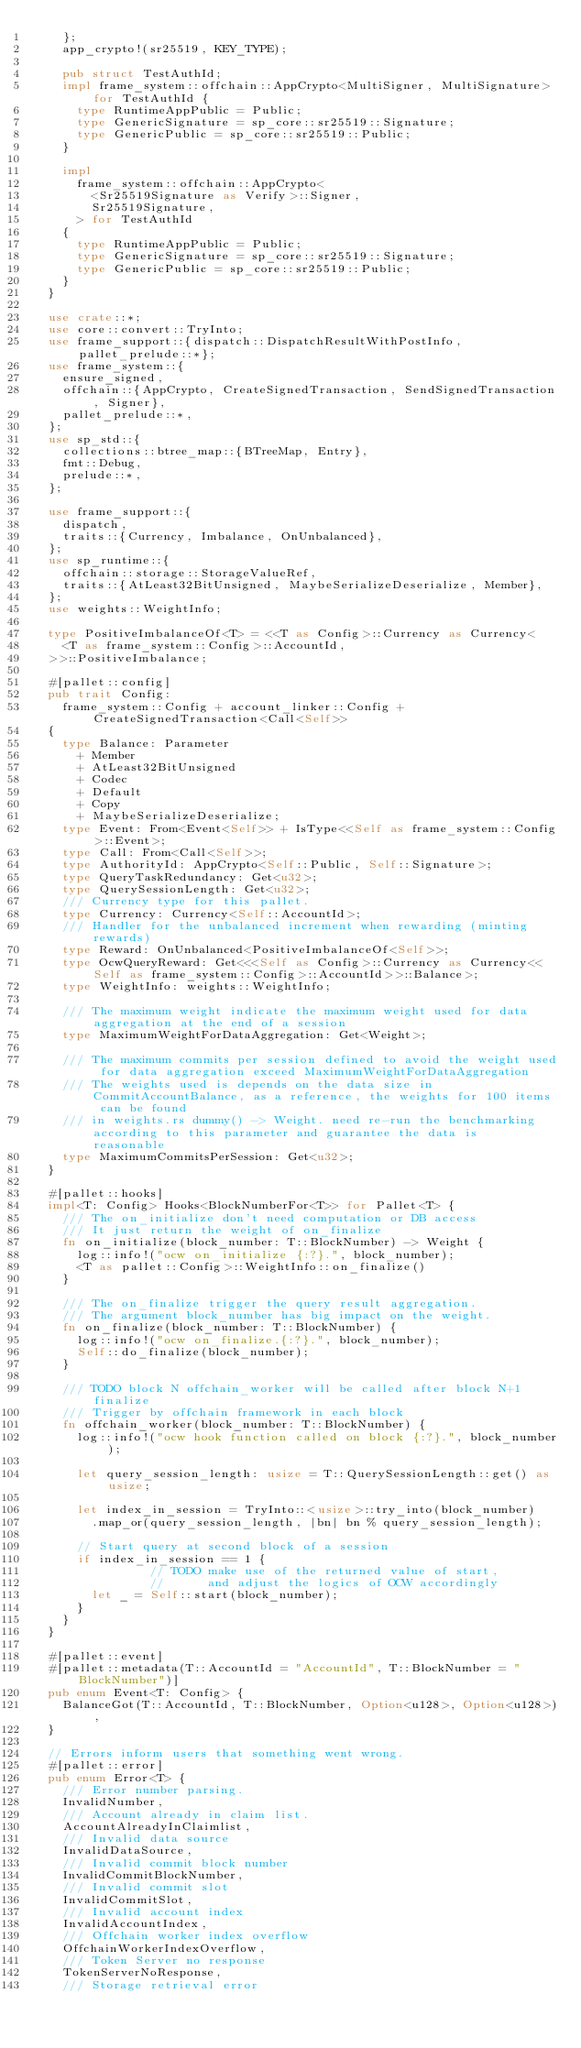<code> <loc_0><loc_0><loc_500><loc_500><_Rust_>		};
		app_crypto!(sr25519, KEY_TYPE);

		pub struct TestAuthId;
		impl frame_system::offchain::AppCrypto<MultiSigner, MultiSignature> for TestAuthId {
			type RuntimeAppPublic = Public;
			type GenericSignature = sp_core::sr25519::Signature;
			type GenericPublic = sp_core::sr25519::Public;
		}

		impl
			frame_system::offchain::AppCrypto<
				<Sr25519Signature as Verify>::Signer,
				Sr25519Signature,
			> for TestAuthId
		{
			type RuntimeAppPublic = Public;
			type GenericSignature = sp_core::sr25519::Signature;
			type GenericPublic = sp_core::sr25519::Public;
		}
	}

	use crate::*;
	use core::convert::TryInto;
	use frame_support::{dispatch::DispatchResultWithPostInfo, pallet_prelude::*};
	use frame_system::{
		ensure_signed,
		offchain::{AppCrypto, CreateSignedTransaction, SendSignedTransaction, Signer},
		pallet_prelude::*,
	};
	use sp_std::{
		collections::btree_map::{BTreeMap, Entry},
		fmt::Debug,
		prelude::*,
	};

	use frame_support::{
		dispatch,
		traits::{Currency, Imbalance, OnUnbalanced},
	};
	use sp_runtime::{
		offchain::storage::StorageValueRef,
		traits::{AtLeast32BitUnsigned, MaybeSerializeDeserialize, Member},
	};
	use weights::WeightInfo;

	type PositiveImbalanceOf<T> = <<T as Config>::Currency as Currency<
		<T as frame_system::Config>::AccountId,
	>>::PositiveImbalance;

	#[pallet::config]
	pub trait Config:
		frame_system::Config + account_linker::Config + CreateSignedTransaction<Call<Self>>
	{
		type Balance: Parameter
			+ Member
			+ AtLeast32BitUnsigned
			+ Codec
			+ Default
			+ Copy
			+ MaybeSerializeDeserialize;
		type Event: From<Event<Self>> + IsType<<Self as frame_system::Config>::Event>;
		type Call: From<Call<Self>>;
		type AuthorityId: AppCrypto<Self::Public, Self::Signature>;
		type QueryTaskRedundancy: Get<u32>;
		type QuerySessionLength: Get<u32>;
		/// Currency type for this pallet.
		type Currency: Currency<Self::AccountId>;
		/// Handler for the unbalanced increment when rewarding (minting rewards)
		type Reward: OnUnbalanced<PositiveImbalanceOf<Self>>;
		type OcwQueryReward: Get<<<Self as Config>::Currency as Currency<<Self as frame_system::Config>::AccountId>>::Balance>;
		type WeightInfo: weights::WeightInfo;

		/// The maximum weight indicate the maximum weight used for data aggregation at the end of a session
		type MaximumWeightForDataAggregation: Get<Weight>;

		/// The maximum commits per session defined to avoid the weight used for data aggregation exceed MaximumWeightForDataAggregation
		/// The weights used is depends on the data size in CommitAccountBalance, as a reference, the weights for 100 items can be found
		/// in weights.rs dummy() -> Weight. need re-run the benchmarking according to this parameter and guarantee the data is reasonable
		type MaximumCommitsPerSession: Get<u32>;
	}

	#[pallet::hooks]
	impl<T: Config> Hooks<BlockNumberFor<T>> for Pallet<T> {
		/// The on_initialize don't need computation or DB access
		/// It just return the weight of on_finalize
		fn on_initialize(block_number: T::BlockNumber) -> Weight {
			log::info!("ocw on_initialize {:?}.", block_number);
			<T as pallet::Config>::WeightInfo::on_finalize()
		}

		/// The on_finalize trigger the query result aggregation.
		/// The argument block_number has big impact on the weight.
		fn on_finalize(block_number: T::BlockNumber) {
			log::info!("ocw on_finalize.{:?}.", block_number);
			Self::do_finalize(block_number);
		}

		/// TODO block N offchain_worker will be called after block N+1 finalize
		/// Trigger by offchain framework in each block
		fn offchain_worker(block_number: T::BlockNumber) {
			log::info!("ocw hook function called on block {:?}.", block_number);

			let query_session_length: usize = T::QuerySessionLength::get() as usize;

			let index_in_session = TryInto::<usize>::try_into(block_number)
				.map_or(query_session_length, |bn| bn % query_session_length);

			// Start query at second block of a session
			if index_in_session == 1 {
                // TODO make use of the returned value of start,
                //      and adjust the logics of OCW accordingly
				let _ = Self::start(block_number);
			}
		}
	}

	#[pallet::event]
	#[pallet::metadata(T::AccountId = "AccountId", T::BlockNumber = "BlockNumber")]
	pub enum Event<T: Config> {
		BalanceGot(T::AccountId, T::BlockNumber, Option<u128>, Option<u128>),
	}

	// Errors inform users that something went wrong.
	#[pallet::error]
	pub enum Error<T> {
		/// Error number parsing.
		InvalidNumber,
		/// Account already in claim list.
		AccountAlreadyInClaimlist,
		/// Invalid data source
		InvalidDataSource,
		/// Invalid commit block number
		InvalidCommitBlockNumber,
		/// Invalid commit slot
		InvalidCommitSlot,
		/// Invalid account index
		InvalidAccountIndex,
		/// Offchain worker index overflow
		OffchainWorkerIndexOverflow,
		/// Token Server no response
		TokenServerNoResponse,
		/// Storage retrieval error</code> 